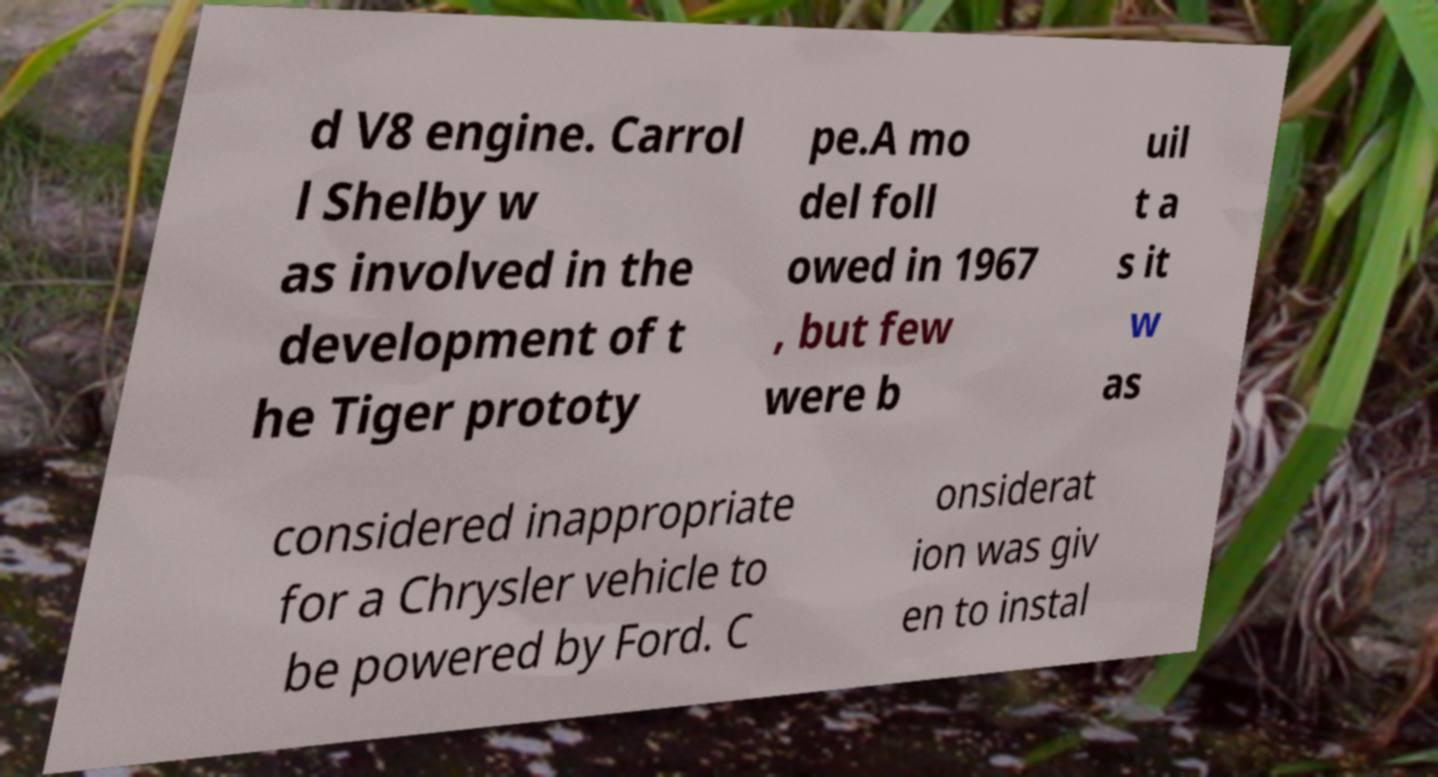There's text embedded in this image that I need extracted. Can you transcribe it verbatim? d V8 engine. Carrol l Shelby w as involved in the development of t he Tiger prototy pe.A mo del foll owed in 1967 , but few were b uil t a s it w as considered inappropriate for a Chrysler vehicle to be powered by Ford. C onsiderat ion was giv en to instal 